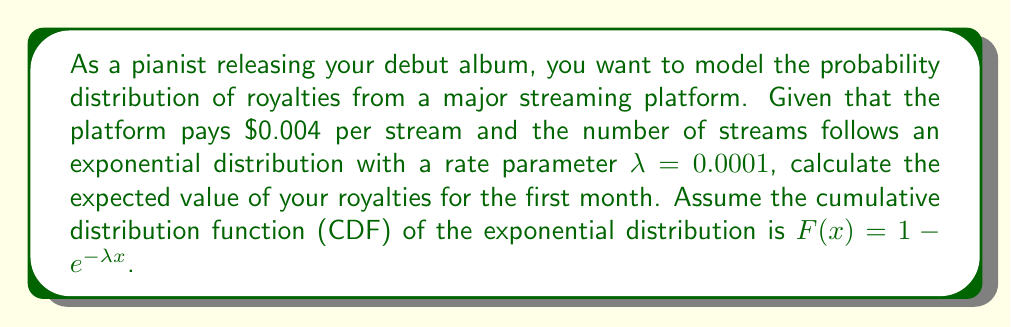Show me your answer to this math problem. Let's approach this step-by-step:

1) First, we need to define our random variable. Let X be the number of streams in the first month.

2) The royalty per stream is $0.004, so our royalty function R(x) is:
   $R(x) = 0.004x$

3) To find the expected value of royalties, we need to integrate R(x) multiplied by the probability density function (PDF) of X from 0 to infinity:

   $E[R(X)] = \int_0^{\infty} R(x) \cdot f(x) dx$

4) For an exponential distribution, the PDF is:
   $f(x) = λe^{-λx}$

5) Substituting our royalty function and PDF:

   $E[R(X)] = \int_0^{\infty} 0.004x \cdot 0.0001e^{-0.0001x} dx$

6) Simplifying:

   $E[R(X)] = 0.0000004 \int_0^{\infty} xe^{-0.0001x} dx$

7) This integral can be solved using integration by parts. Let u = x and dv = e^{-0.0001x}dx:

   $E[R(X)] = 0.0000004 \left[ -10000xe^{-0.0001x} \bigg|_0^{\infty} + 10000 \int_0^{\infty} e^{-0.0001x} dx \right]$

8) Evaluating the limits and solving the remaining integral:

   $E[R(X)] = 0.0000004 \left[ 0 + 10000 \cdot (-10000e^{-0.0001x}) \bigg|_0^{\infty} \right]$
   $E[R(X)] = 0.0000004 \cdot 10000 \cdot 10000 = 40$

Therefore, the expected value of royalties for the first month is $40.
Answer: $40 